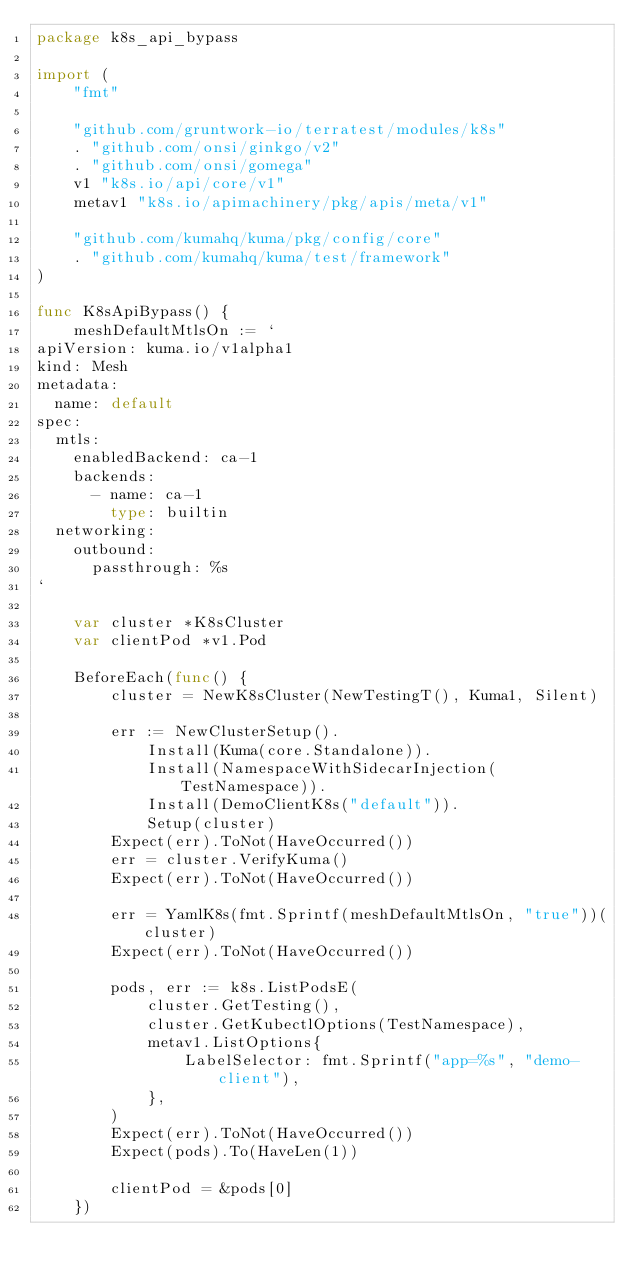Convert code to text. <code><loc_0><loc_0><loc_500><loc_500><_Go_>package k8s_api_bypass

import (
	"fmt"

	"github.com/gruntwork-io/terratest/modules/k8s"
	. "github.com/onsi/ginkgo/v2"
	. "github.com/onsi/gomega"
	v1 "k8s.io/api/core/v1"
	metav1 "k8s.io/apimachinery/pkg/apis/meta/v1"

	"github.com/kumahq/kuma/pkg/config/core"
	. "github.com/kumahq/kuma/test/framework"
)

func K8sApiBypass() {
	meshDefaultMtlsOn := `
apiVersion: kuma.io/v1alpha1
kind: Mesh
metadata:
  name: default
spec:
  mtls:
    enabledBackend: ca-1
    backends:
      - name: ca-1
        type: builtin
  networking:
    outbound:
      passthrough: %s
`

	var cluster *K8sCluster
	var clientPod *v1.Pod

	BeforeEach(func() {
		cluster = NewK8sCluster(NewTestingT(), Kuma1, Silent)

		err := NewClusterSetup().
			Install(Kuma(core.Standalone)).
			Install(NamespaceWithSidecarInjection(TestNamespace)).
			Install(DemoClientK8s("default")).
			Setup(cluster)
		Expect(err).ToNot(HaveOccurred())
		err = cluster.VerifyKuma()
		Expect(err).ToNot(HaveOccurred())

		err = YamlK8s(fmt.Sprintf(meshDefaultMtlsOn, "true"))(cluster)
		Expect(err).ToNot(HaveOccurred())

		pods, err := k8s.ListPodsE(
			cluster.GetTesting(),
			cluster.GetKubectlOptions(TestNamespace),
			metav1.ListOptions{
				LabelSelector: fmt.Sprintf("app=%s", "demo-client"),
			},
		)
		Expect(err).ToNot(HaveOccurred())
		Expect(pods).To(HaveLen(1))

		clientPod = &pods[0]
	})
</code> 